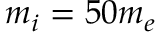<formula> <loc_0><loc_0><loc_500><loc_500>m _ { i } = 5 0 m _ { e }</formula> 